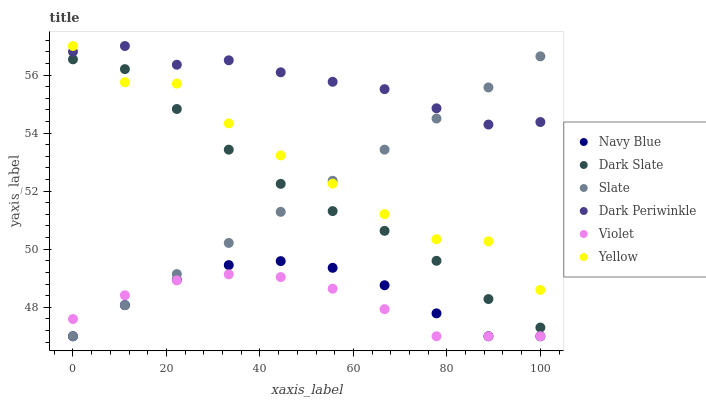Does Violet have the minimum area under the curve?
Answer yes or no. Yes. Does Dark Periwinkle have the maximum area under the curve?
Answer yes or no. Yes. Does Slate have the minimum area under the curve?
Answer yes or no. No. Does Slate have the maximum area under the curve?
Answer yes or no. No. Is Slate the smoothest?
Answer yes or no. Yes. Is Yellow the roughest?
Answer yes or no. Yes. Is Yellow the smoothest?
Answer yes or no. No. Is Slate the roughest?
Answer yes or no. No. Does Navy Blue have the lowest value?
Answer yes or no. Yes. Does Yellow have the lowest value?
Answer yes or no. No. Does Dark Periwinkle have the highest value?
Answer yes or no. Yes. Does Slate have the highest value?
Answer yes or no. No. Is Navy Blue less than Dark Periwinkle?
Answer yes or no. Yes. Is Dark Slate greater than Navy Blue?
Answer yes or no. Yes. Does Yellow intersect Dark Slate?
Answer yes or no. Yes. Is Yellow less than Dark Slate?
Answer yes or no. No. Is Yellow greater than Dark Slate?
Answer yes or no. No. Does Navy Blue intersect Dark Periwinkle?
Answer yes or no. No. 